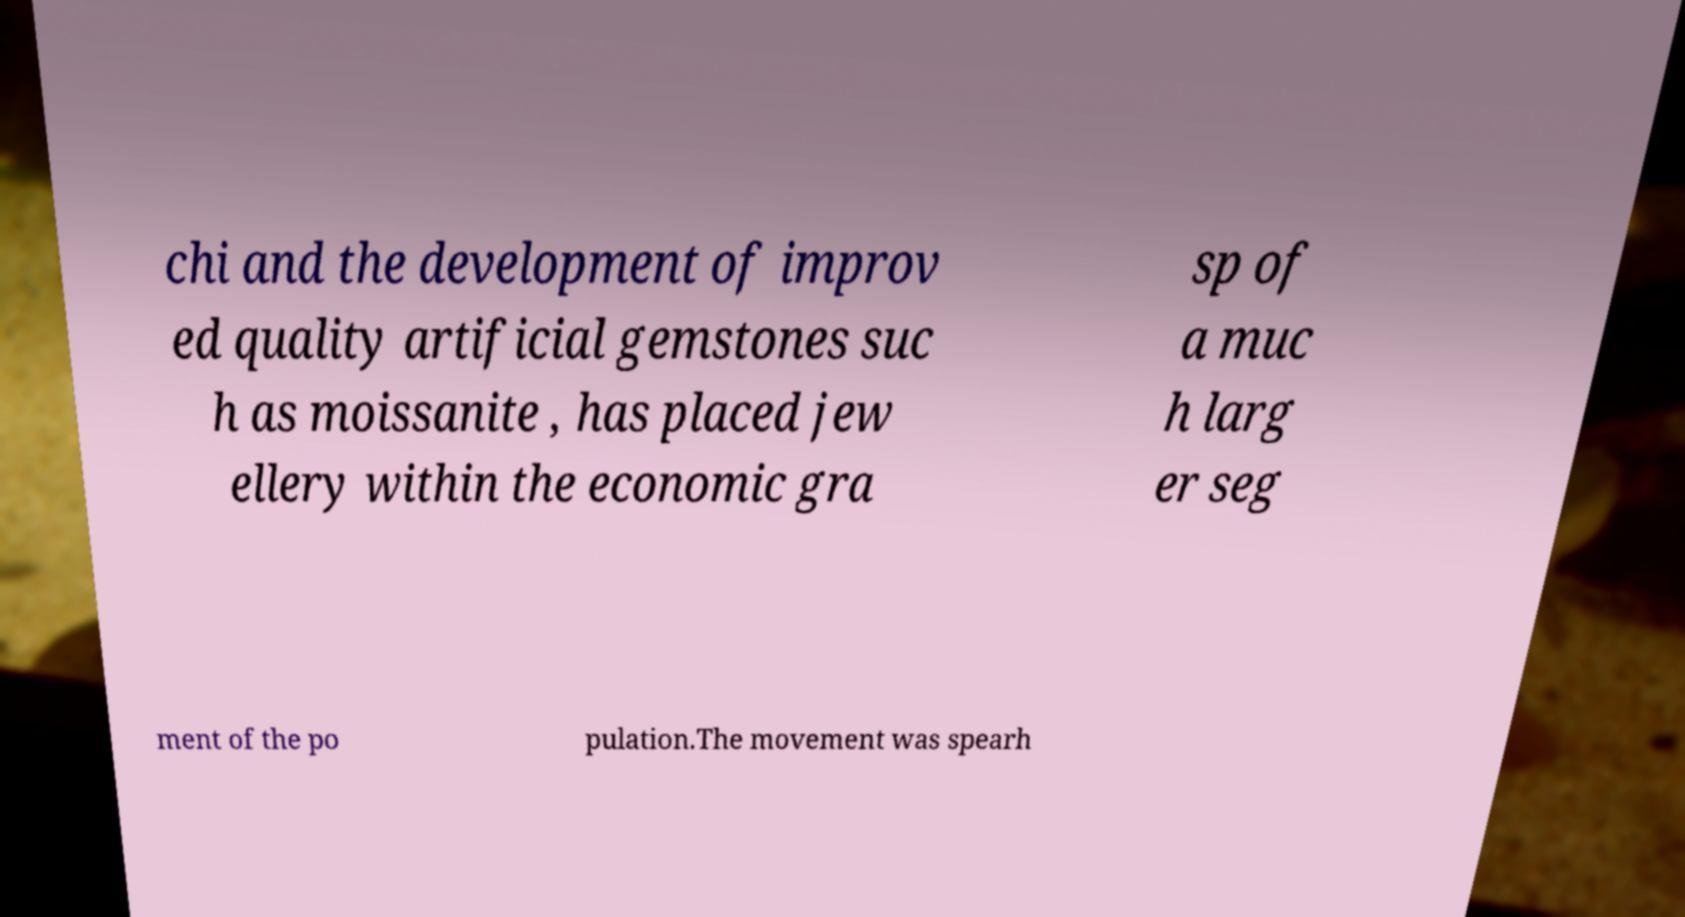Could you extract and type out the text from this image? chi and the development of improv ed quality artificial gemstones suc h as moissanite , has placed jew ellery within the economic gra sp of a muc h larg er seg ment of the po pulation.The movement was spearh 